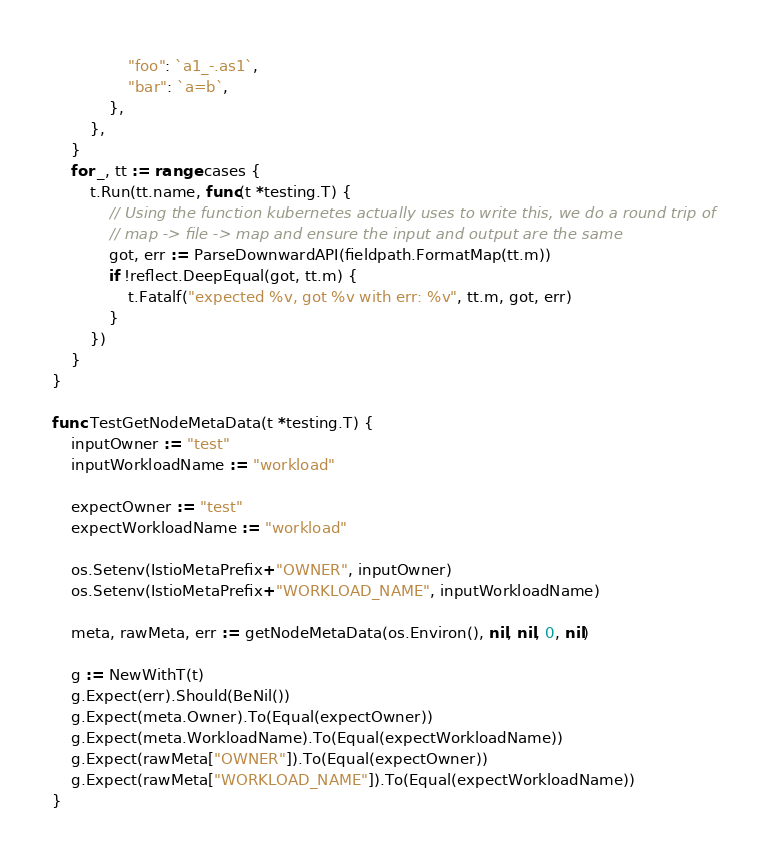Convert code to text. <code><loc_0><loc_0><loc_500><loc_500><_Go_>				"foo": `a1_-.as1`,
				"bar": `a=b`,
			},
		},
	}
	for _, tt := range cases {
		t.Run(tt.name, func(t *testing.T) {
			// Using the function kubernetes actually uses to write this, we do a round trip of
			// map -> file -> map and ensure the input and output are the same
			got, err := ParseDownwardAPI(fieldpath.FormatMap(tt.m))
			if !reflect.DeepEqual(got, tt.m) {
				t.Fatalf("expected %v, got %v with err: %v", tt.m, got, err)
			}
		})
	}
}

func TestGetNodeMetaData(t *testing.T) {
	inputOwner := "test"
	inputWorkloadName := "workload"

	expectOwner := "test"
	expectWorkloadName := "workload"

	os.Setenv(IstioMetaPrefix+"OWNER", inputOwner)
	os.Setenv(IstioMetaPrefix+"WORKLOAD_NAME", inputWorkloadName)

	meta, rawMeta, err := getNodeMetaData(os.Environ(), nil, nil, 0, nil)

	g := NewWithT(t)
	g.Expect(err).Should(BeNil())
	g.Expect(meta.Owner).To(Equal(expectOwner))
	g.Expect(meta.WorkloadName).To(Equal(expectWorkloadName))
	g.Expect(rawMeta["OWNER"]).To(Equal(expectOwner))
	g.Expect(rawMeta["WORKLOAD_NAME"]).To(Equal(expectWorkloadName))
}
</code> 